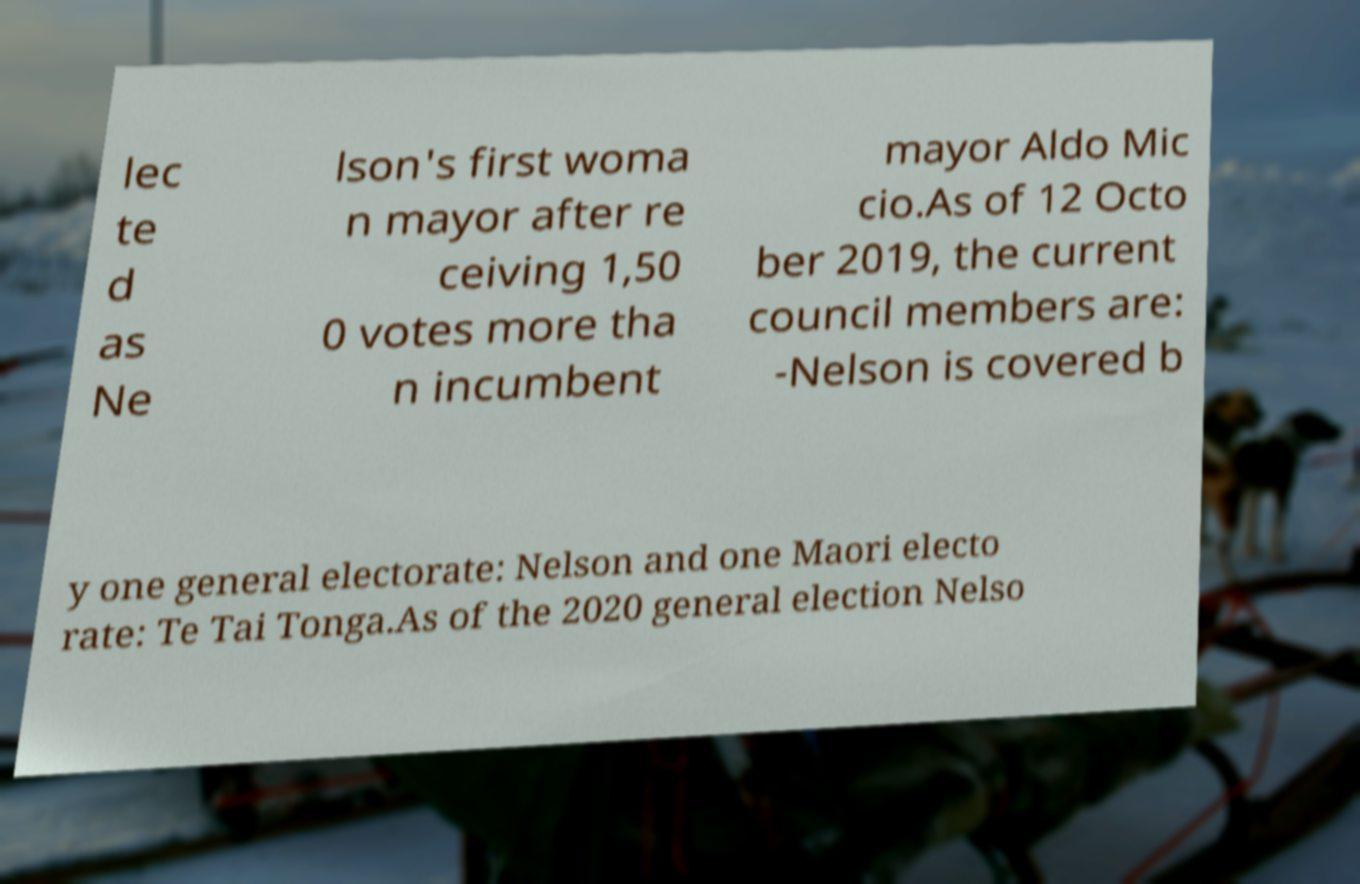What messages or text are displayed in this image? I need them in a readable, typed format. lec te d as Ne lson's first woma n mayor after re ceiving 1,50 0 votes more tha n incumbent mayor Aldo Mic cio.As of 12 Octo ber 2019, the current council members are: -Nelson is covered b y one general electorate: Nelson and one Maori electo rate: Te Tai Tonga.As of the 2020 general election Nelso 